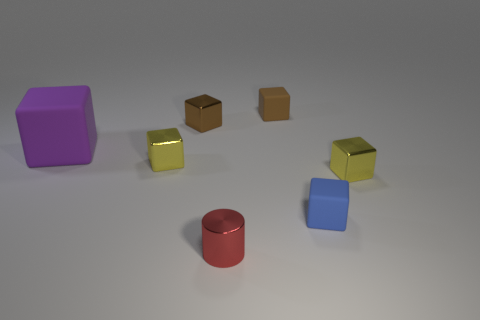There is a small rubber block that is right of the rubber cube that is behind the big block in front of the brown matte object; what color is it?
Your answer should be very brief. Blue. There is a purple object that is behind the tiny red cylinder; what is its shape?
Provide a succinct answer. Cube. Is there any other thing that has the same shape as the red object?
Ensure brevity in your answer.  No. There is a cylinder; what number of things are in front of it?
Your answer should be compact. 0. Are there the same number of tiny shiny things that are behind the small red cylinder and matte things?
Provide a succinct answer. Yes. Do the blue cube and the big purple cube have the same material?
Keep it short and to the point. Yes. How big is the matte thing that is both behind the small blue matte block and in front of the tiny brown metal block?
Offer a terse response. Large. What number of yellow blocks are the same size as the purple rubber block?
Offer a terse response. 0. What is the size of the brown metal cube behind the rubber object in front of the big purple block?
Keep it short and to the point. Small. Is the shape of the metal object that is to the right of the blue thing the same as the metal thing in front of the small blue object?
Your response must be concise. No. 